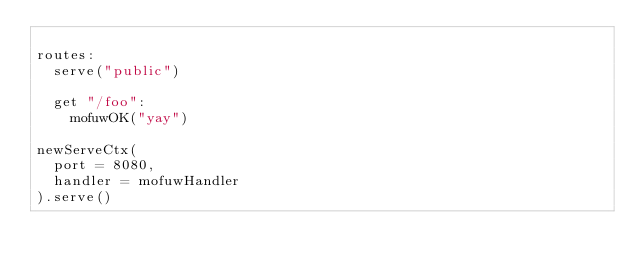<code> <loc_0><loc_0><loc_500><loc_500><_Nim_>
routes:
  serve("public")

  get "/foo":
    mofuwOK("yay")

newServeCtx(
  port = 8080,
  handler = mofuwHandler
).serve()</code> 